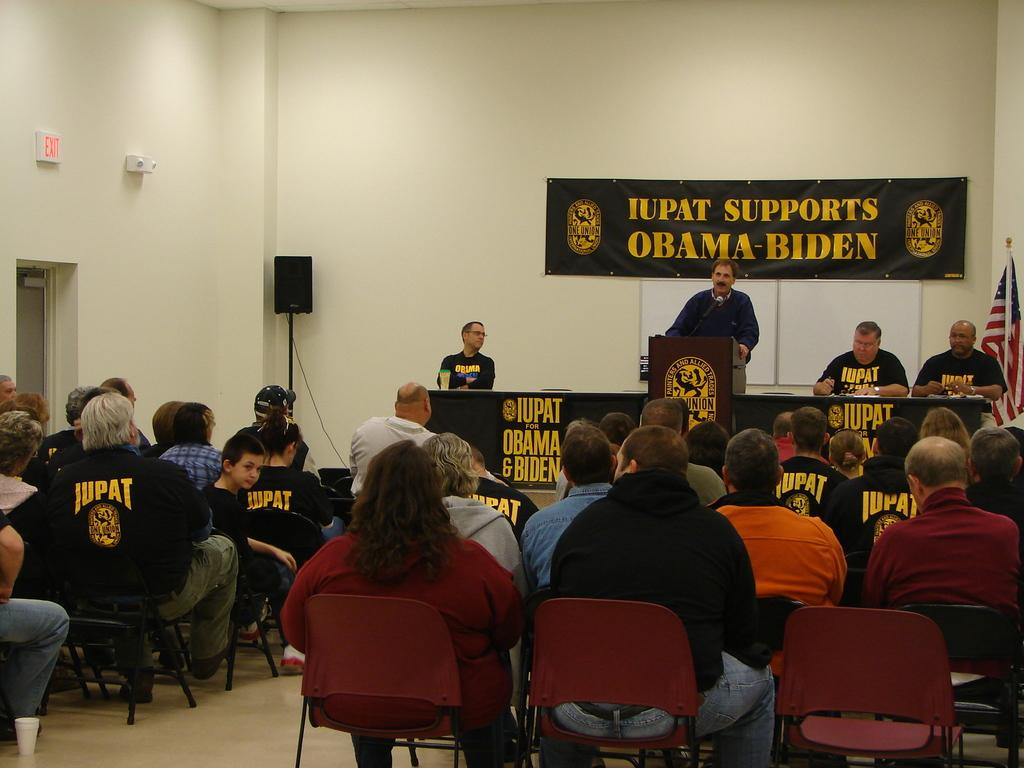What are the people in the image doing? The people in the image are sitting on chairs. What can be seen in the background of the image? There is a speaker and a wall in the background of the image. How many beetles can be seen crawling on the wall in the image? There are no beetles visible in the image; only people sitting on chairs, a speaker, and a wall are present. 